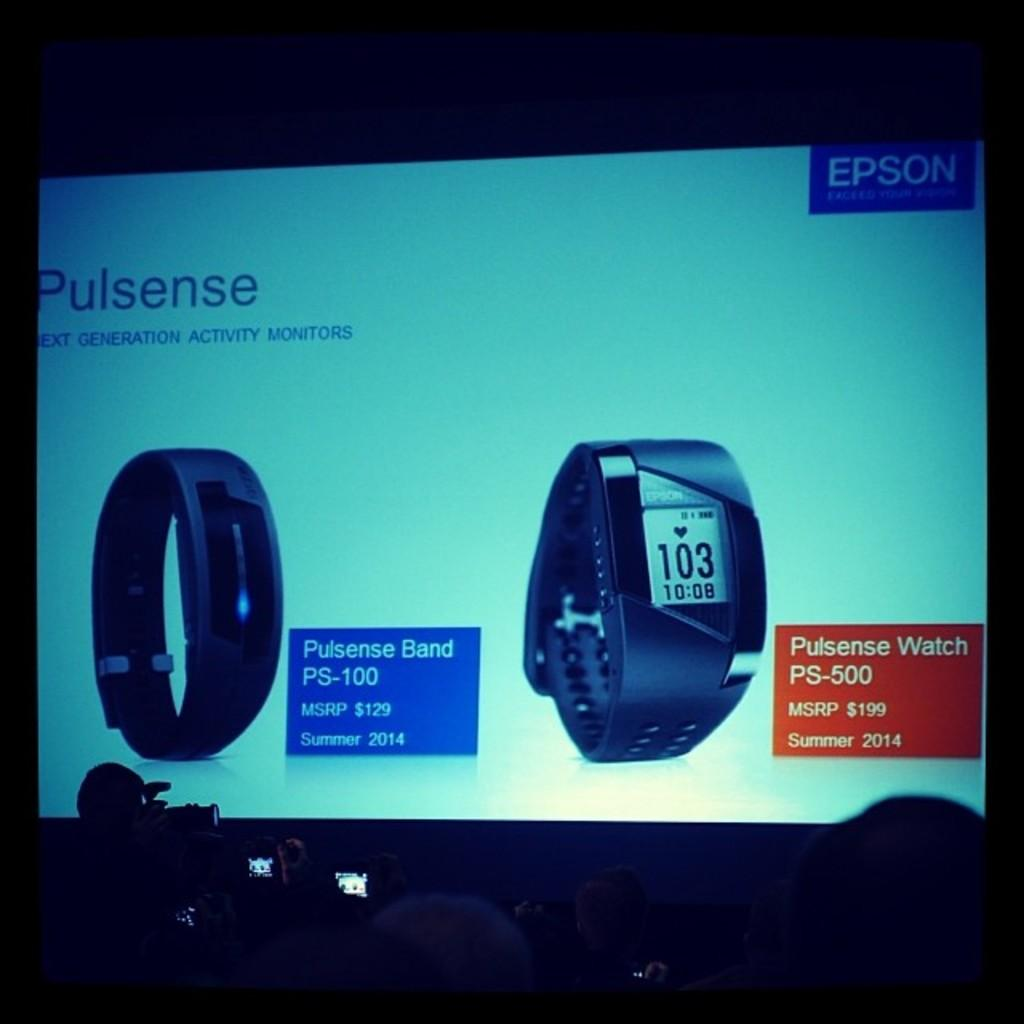<image>
Relay a brief, clear account of the picture shown. A computer screen displaying two different models of the Pulsense activity monitor. 